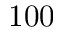Convert formula to latex. <formula><loc_0><loc_0><loc_500><loc_500>1 0 0</formula> 